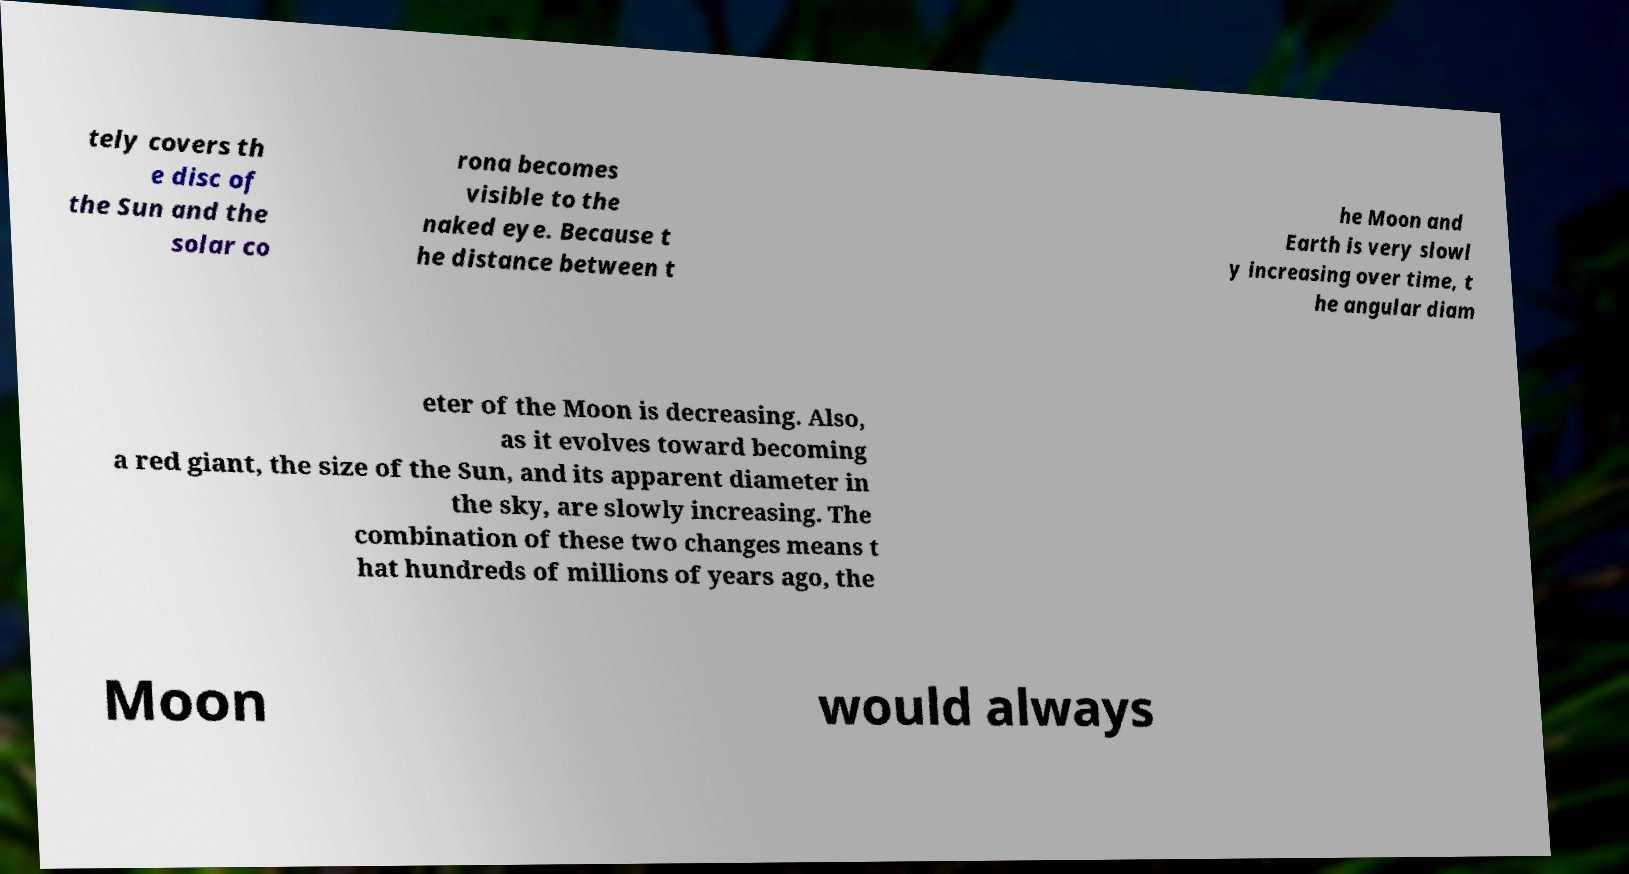I need the written content from this picture converted into text. Can you do that? tely covers th e disc of the Sun and the solar co rona becomes visible to the naked eye. Because t he distance between t he Moon and Earth is very slowl y increasing over time, t he angular diam eter of the Moon is decreasing. Also, as it evolves toward becoming a red giant, the size of the Sun, and its apparent diameter in the sky, are slowly increasing. The combination of these two changes means t hat hundreds of millions of years ago, the Moon would always 